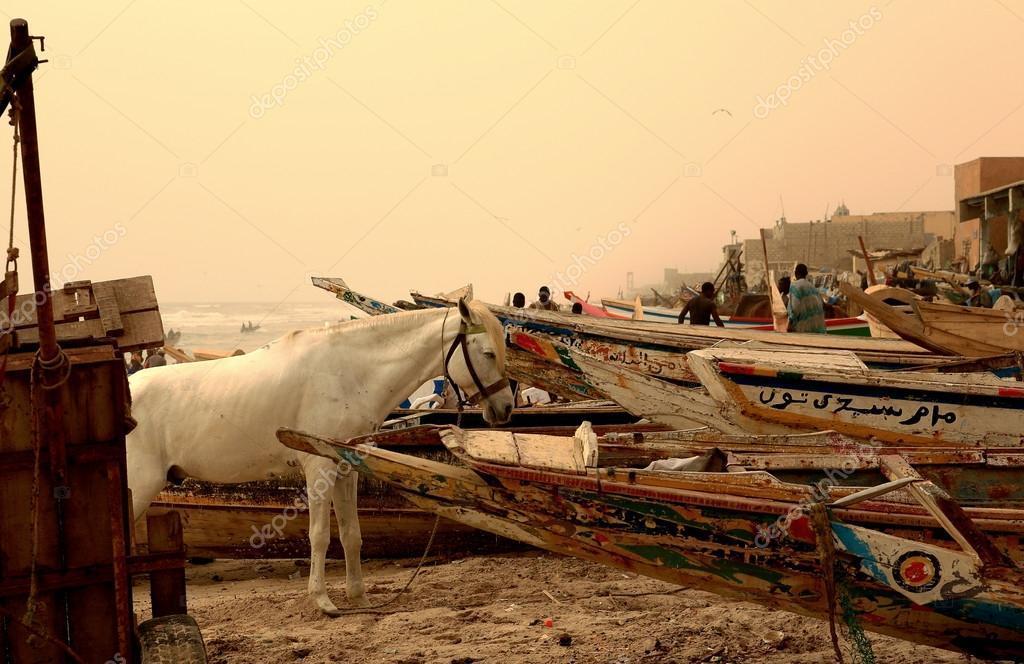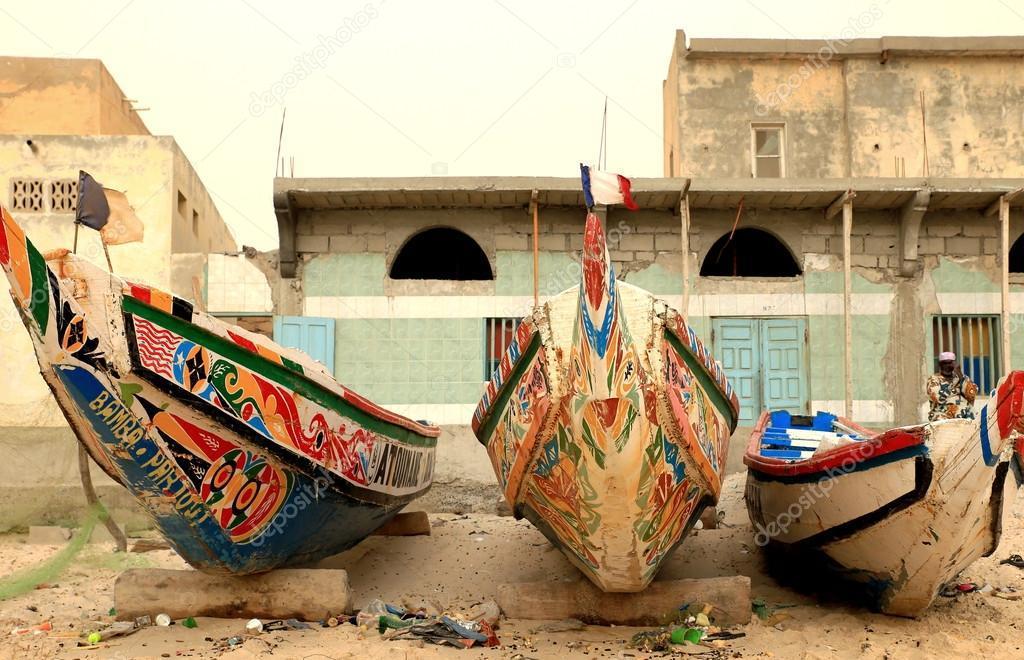The first image is the image on the left, the second image is the image on the right. Given the left and right images, does the statement "In one image there are six or more men in a boat being paddled through water." hold true? Answer yes or no. No. 